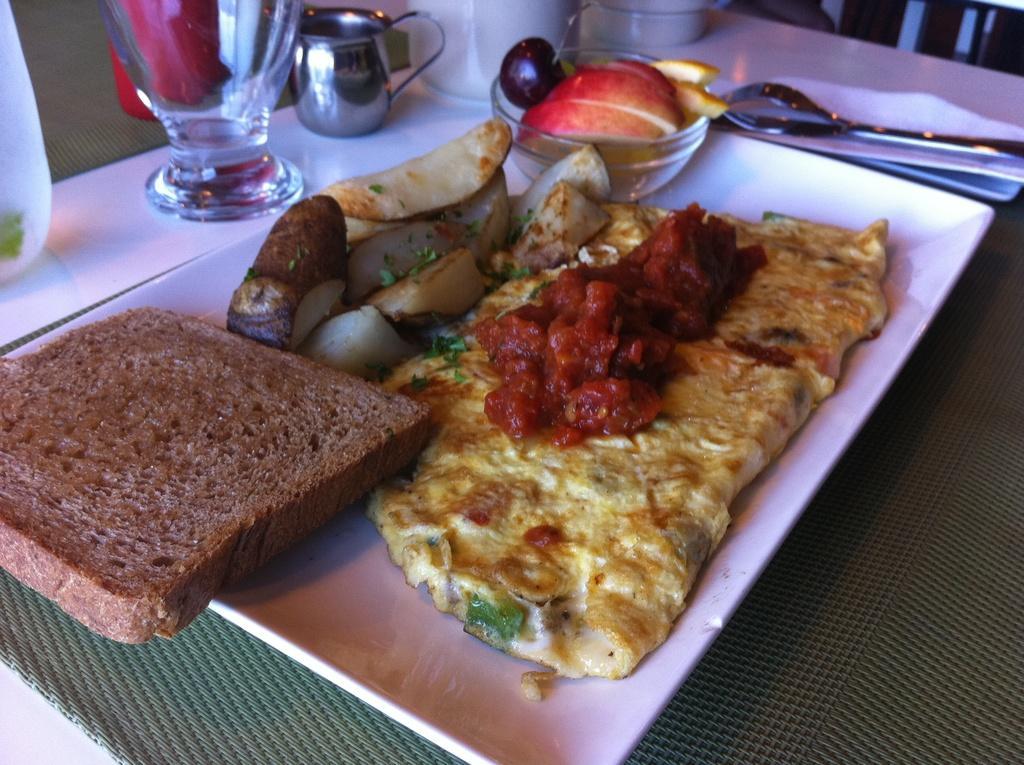In one or two sentences, can you explain what this image depicts? In the image there is brown bread,omelet,pickles and fruits in a plate with spoon and fork beside it on a tissue and there is glass,cup and jug in front of it on a table. 